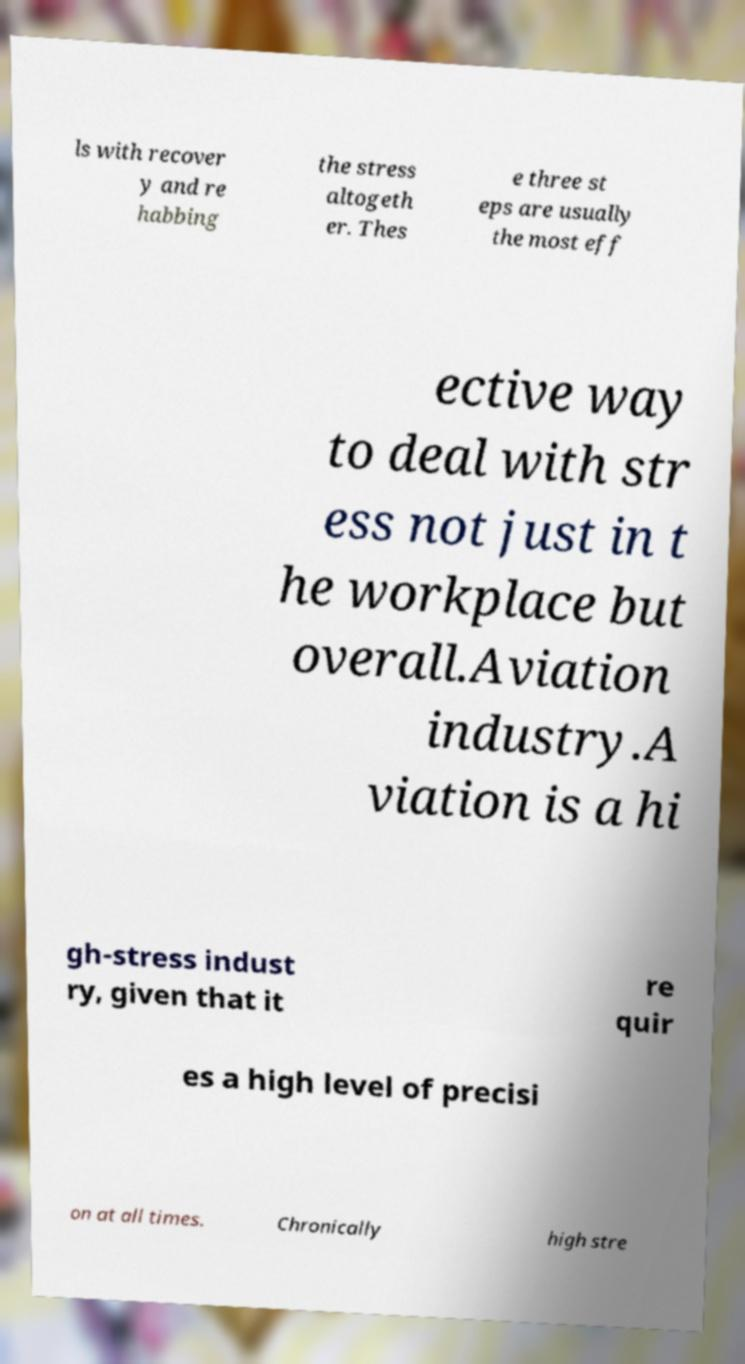For documentation purposes, I need the text within this image transcribed. Could you provide that? ls with recover y and re habbing the stress altogeth er. Thes e three st eps are usually the most eff ective way to deal with str ess not just in t he workplace but overall.Aviation industry.A viation is a hi gh-stress indust ry, given that it re quir es a high level of precisi on at all times. Chronically high stre 